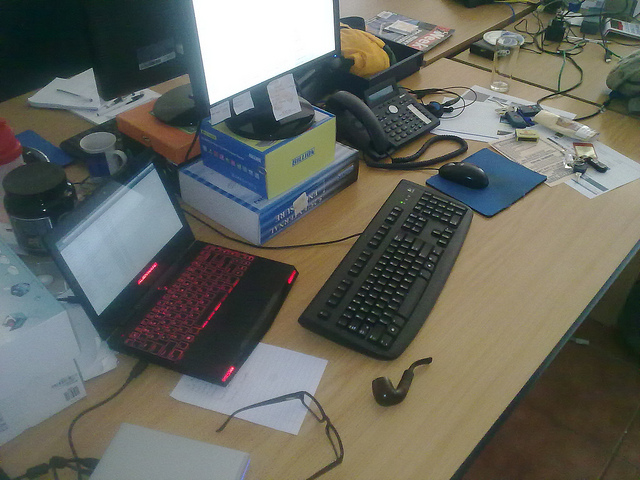Can you describe the overall condition or organization of the workspace? The workspace appears cluttered and somewhat disorganized. There are various items scattered on the desk, including papers, electronic devices, cables, and personal effects. The positioning of monitors on stacks of boxes and the assorted nature of the items suggest a casual approach to workspace management, possibly indicative of a busy or multitasking individual. 